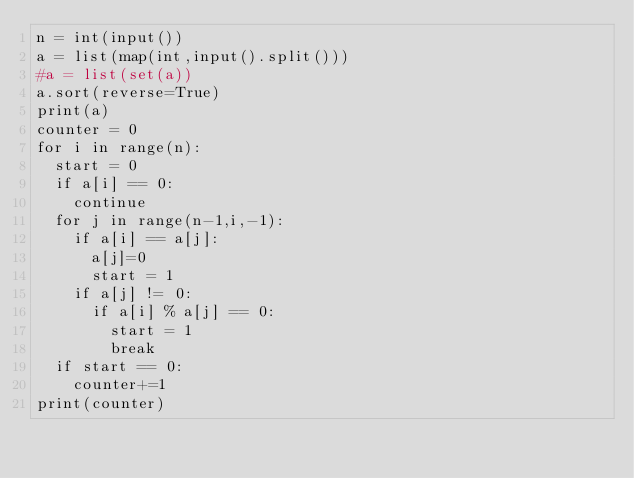<code> <loc_0><loc_0><loc_500><loc_500><_Python_>n = int(input())
a = list(map(int,input().split()))
#a = list(set(a))
a.sort(reverse=True)
print(a)
counter = 0
for i in range(n):
  start = 0
  if a[i] == 0:
    continue
  for j in range(n-1,i,-1):
    if a[i] == a[j]:
      a[j]=0
      start = 1 
    if a[j] != 0:
      if a[i] % a[j] == 0:
        start = 1
        break
  if start == 0:
    counter+=1
print(counter)</code> 